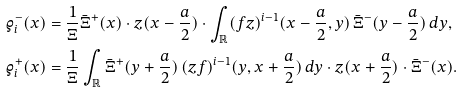Convert formula to latex. <formula><loc_0><loc_0><loc_500><loc_500>\varrho _ { i } ^ { - } ( x ) & = \frac { 1 } { \Xi } \bar { \Xi } ^ { + } ( x ) \cdot z ( x - \frac { a } { 2 } ) \cdot \int _ { \mathbb { R } } ( f z ) ^ { i - 1 } ( x - \frac { a } { 2 } , y ) \, \bar { \Xi } ^ { - } ( y - \frac { a } { 2 } ) \, d y , \\ \varrho _ { i } ^ { + } ( x ) & = \frac { 1 } { \Xi } \int _ { \mathbb { R } } \bar { \Xi } ^ { + } ( y + \frac { a } { 2 } ) \, ( z f ) ^ { i - 1 } ( y , x + \frac { a } { 2 } ) \, d y \cdot z ( x + \frac { a } { 2 } ) \cdot \bar { \Xi } ^ { - } ( x ) .</formula> 